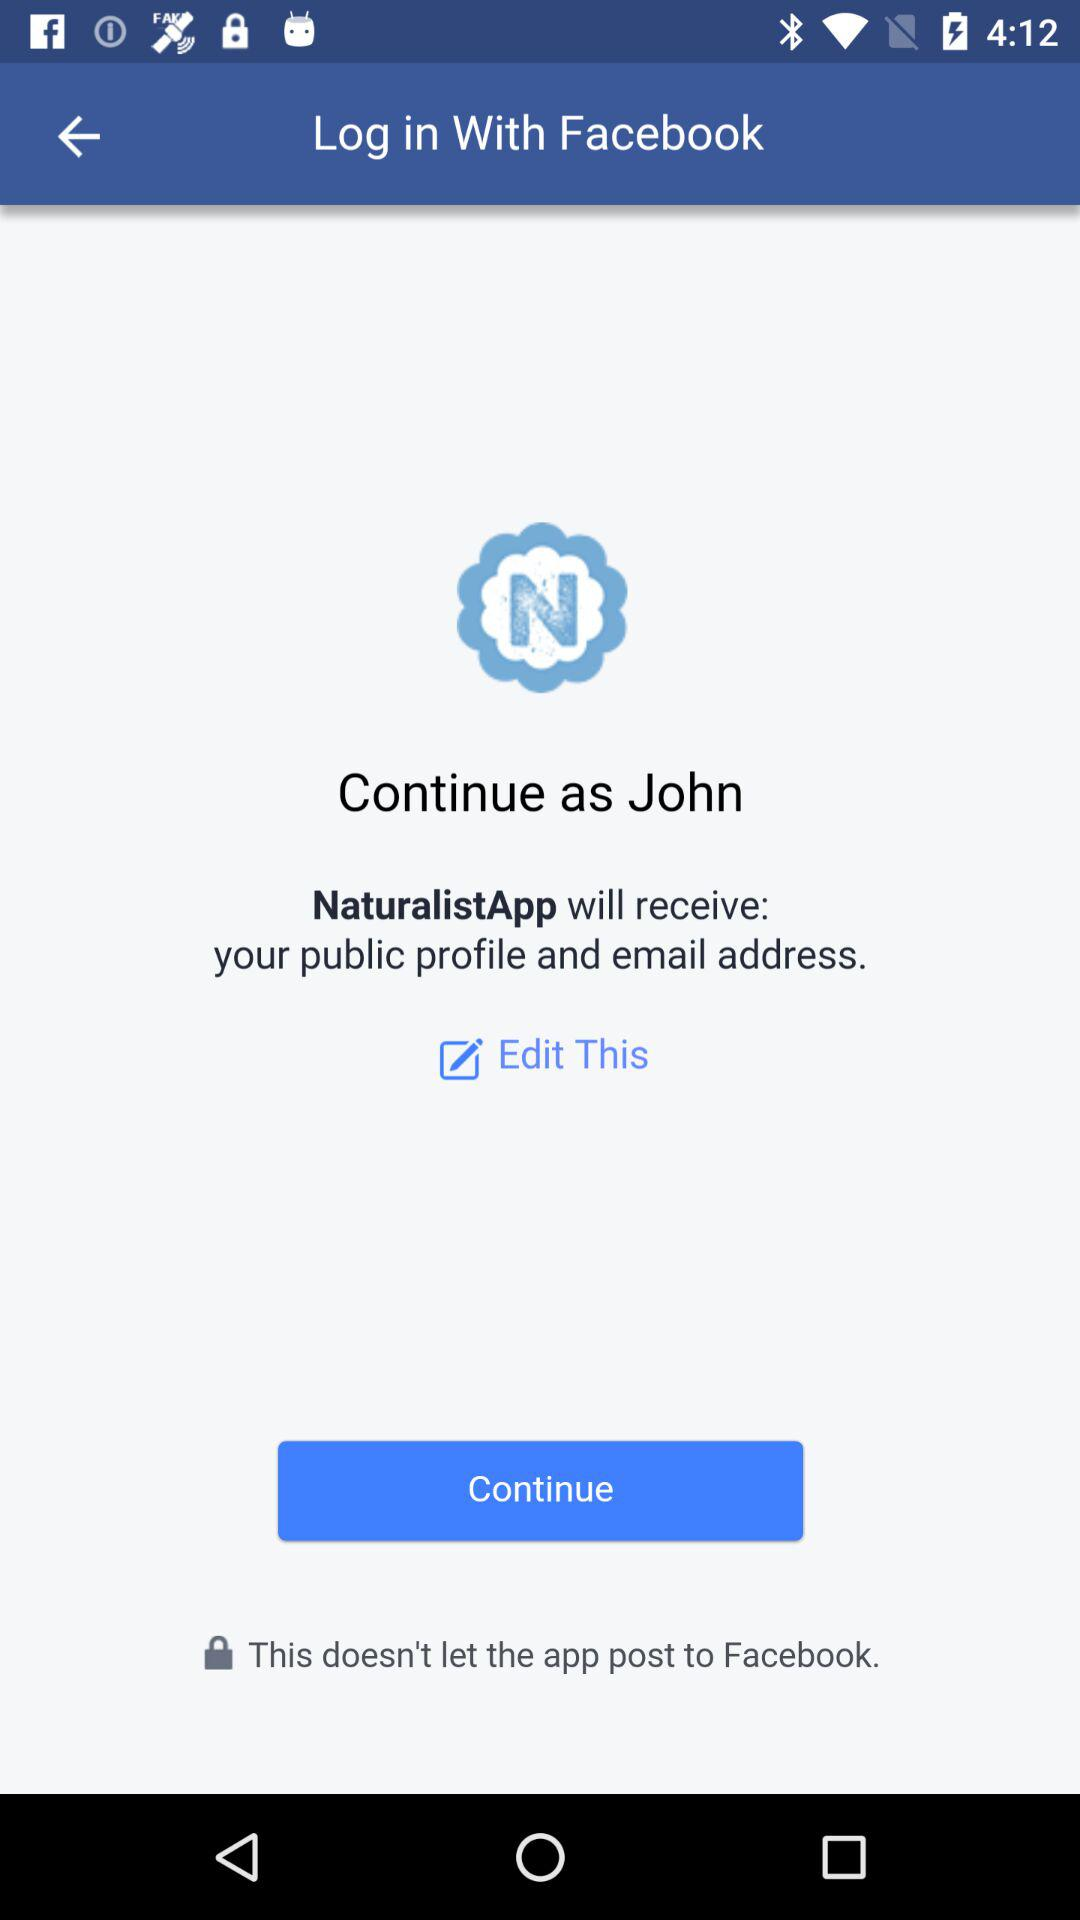What is the name of the user? The name of the user is John. 